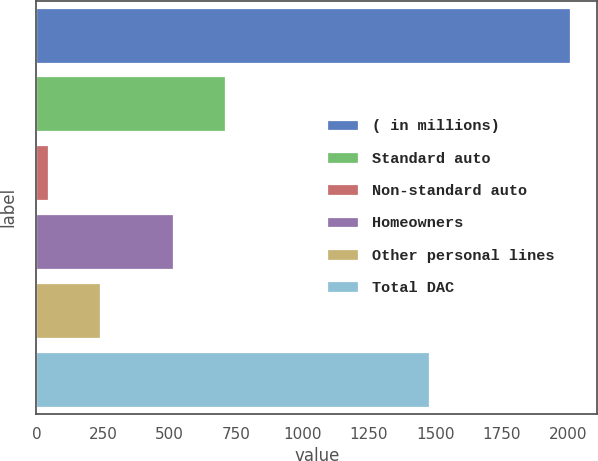Convert chart to OTSL. <chart><loc_0><loc_0><loc_500><loc_500><bar_chart><fcel>( in millions)<fcel>Standard auto<fcel>Non-standard auto<fcel>Homeowners<fcel>Other personal lines<fcel>Total DAC<nl><fcel>2007<fcel>710.3<fcel>44<fcel>514<fcel>240.3<fcel>1477<nl></chart> 